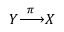Convert formula to latex. <formula><loc_0><loc_0><loc_500><loc_500>Y { \xrightarrow { \pi } } X</formula> 